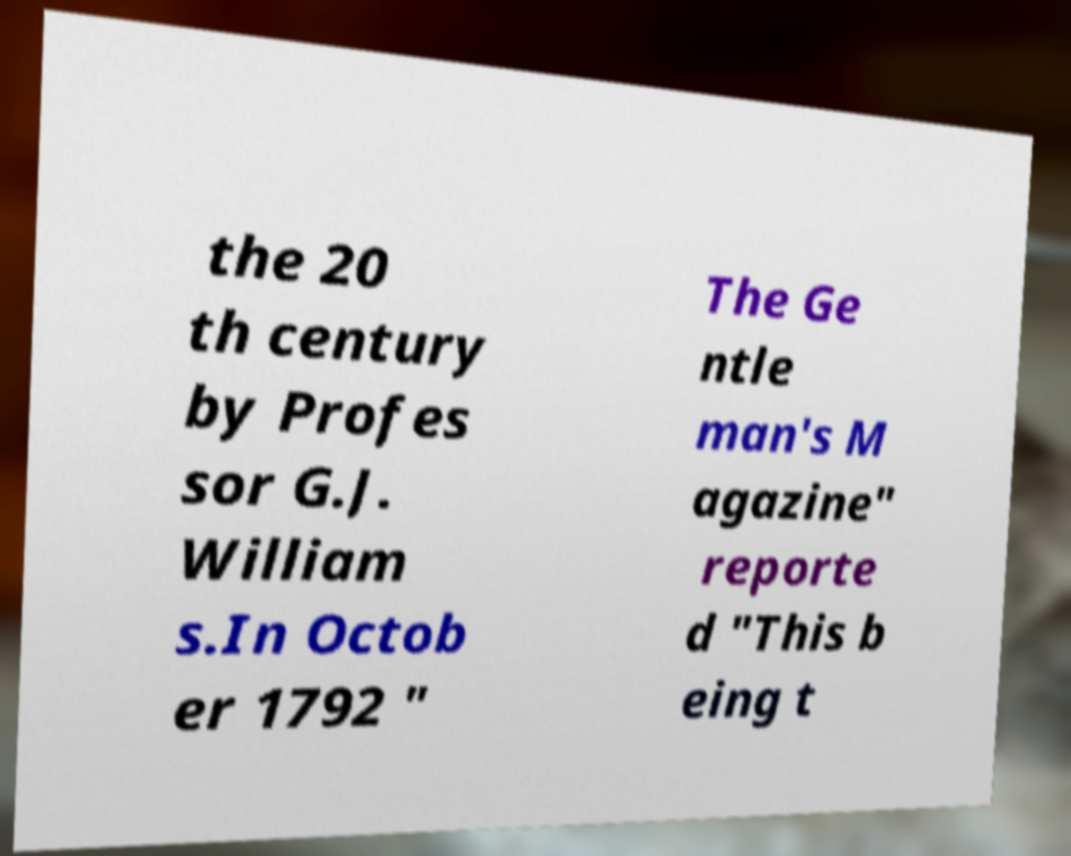Could you extract and type out the text from this image? the 20 th century by Profes sor G.J. William s.In Octob er 1792 " The Ge ntle man's M agazine" reporte d "This b eing t 